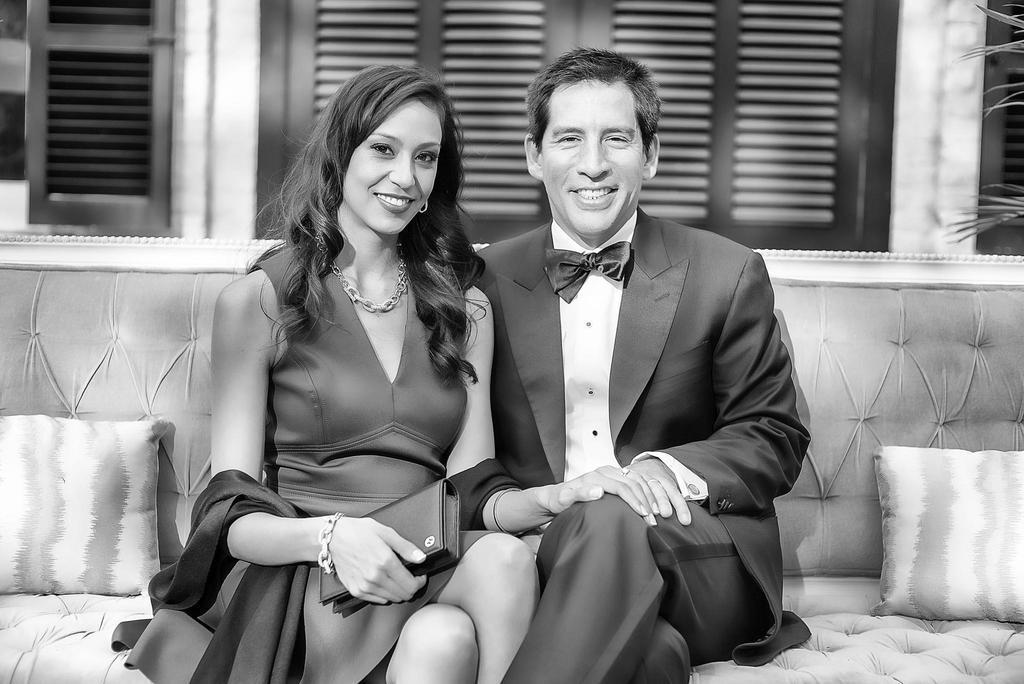Could you give a brief overview of what you see in this image? In this black and white picture we can see 2 people holding hands and sitting on a sofa. They are looking and smiling at someone. In the background, we can see wooden doors, windows, grass, cushions. 